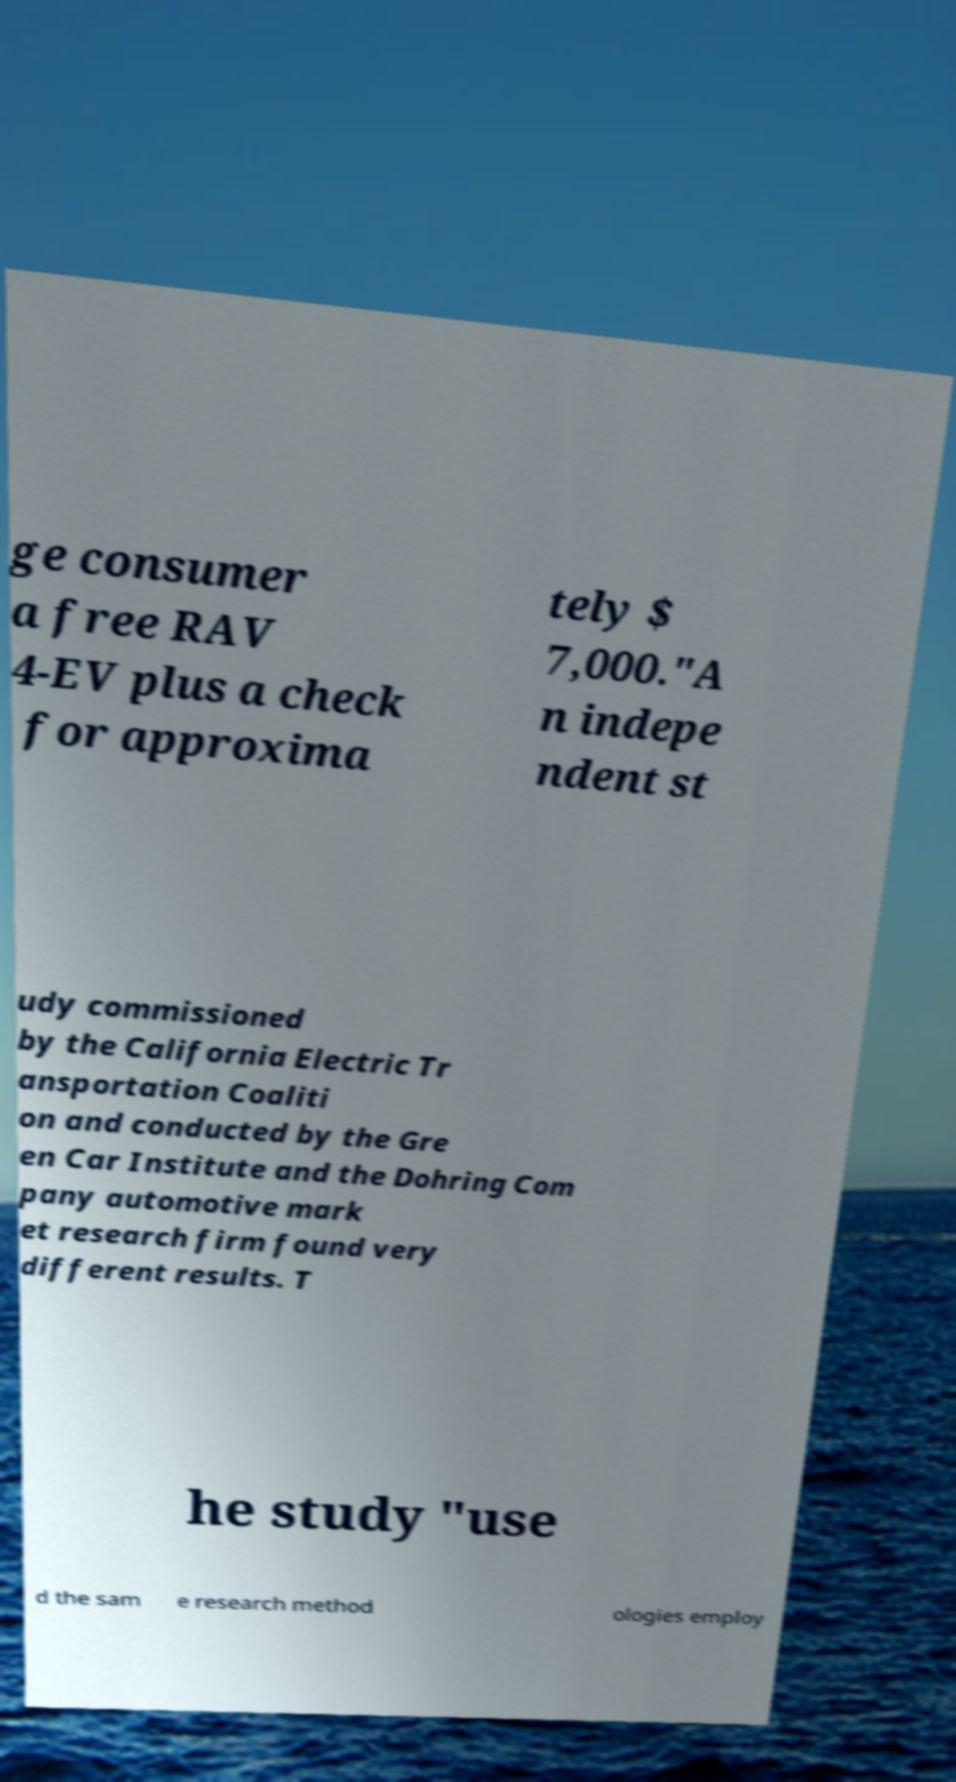Please identify and transcribe the text found in this image. ge consumer a free RAV 4-EV plus a check for approxima tely $ 7,000."A n indepe ndent st udy commissioned by the California Electric Tr ansportation Coaliti on and conducted by the Gre en Car Institute and the Dohring Com pany automotive mark et research firm found very different results. T he study "use d the sam e research method ologies employ 